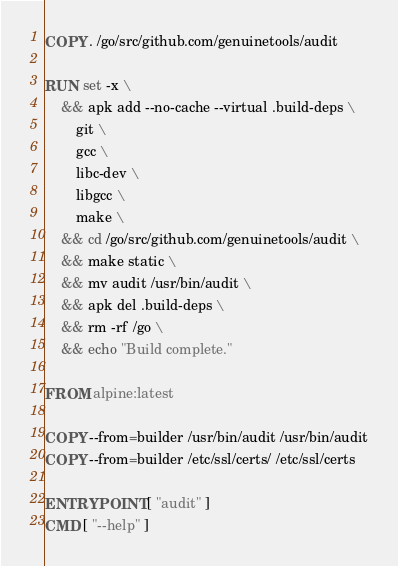<code> <loc_0><loc_0><loc_500><loc_500><_Dockerfile_>COPY . /go/src/github.com/genuinetools/audit

RUN set -x \
	&& apk add --no-cache --virtual .build-deps \
		git \
		gcc \
		libc-dev \
		libgcc \
		make \
	&& cd /go/src/github.com/genuinetools/audit \
	&& make static \
	&& mv audit /usr/bin/audit \
	&& apk del .build-deps \
	&& rm -rf /go \
	&& echo "Build complete."

FROM alpine:latest

COPY --from=builder /usr/bin/audit /usr/bin/audit
COPY --from=builder /etc/ssl/certs/ /etc/ssl/certs

ENTRYPOINT [ "audit" ]
CMD [ "--help" ]
</code> 